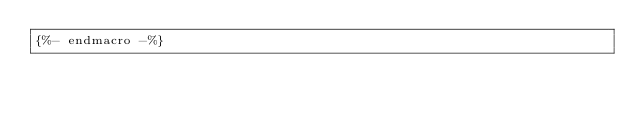Convert code to text. <code><loc_0><loc_0><loc_500><loc_500><_SQL_>{%- endmacro -%}</code> 